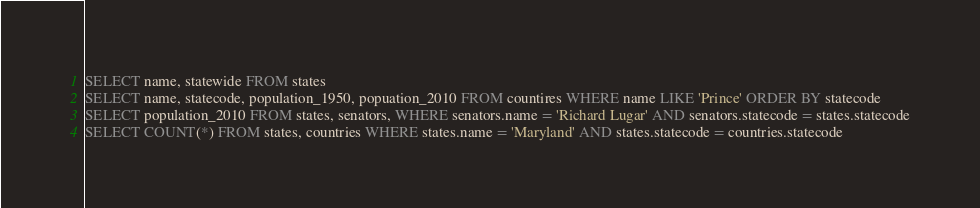<code> <loc_0><loc_0><loc_500><loc_500><_SQL_>SELECT name, statewide FROM states
SELECT name, statecode, population_1950, popuation_2010 FROM countires WHERE name LIKE 'Prince' ORDER BY statecode
SELECT population_2010 FROM states, senators, WHERE senators.name = 'Richard Lugar' AND senators.statecode = states.statecode
SELECT COUNT(*) FROM states, countries WHERE states.name = 'Maryland' AND states.statecode = countries.statecode

</code> 